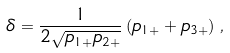Convert formula to latex. <formula><loc_0><loc_0><loc_500><loc_500>\delta = \frac { 1 } { 2 \sqrt { p _ { 1 + } p _ { 2 + } } } \left ( p _ { 1 + } + p _ { 3 + } \right ) \, ,</formula> 